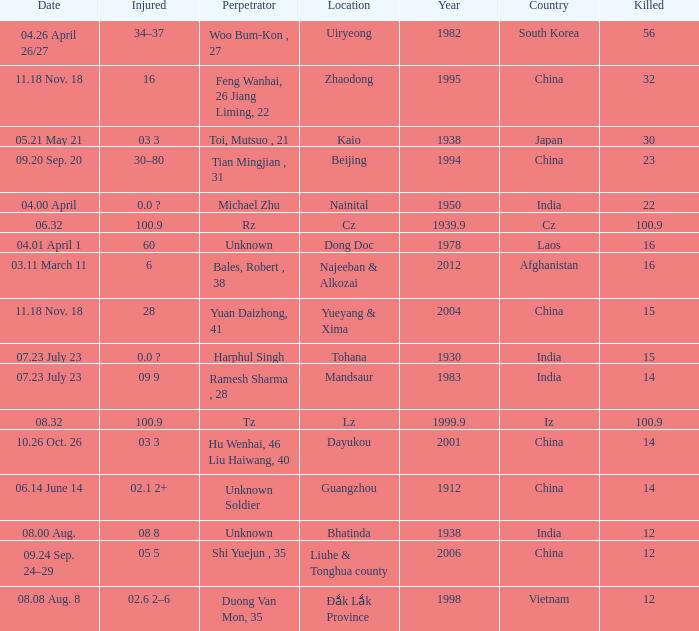What is the average Year, when Date is "04.01 April 1"? 1978.0. 